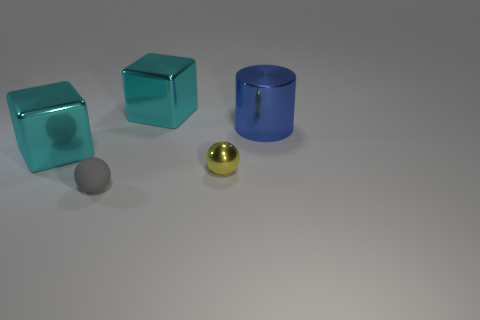What color is the big metal cylinder?
Keep it short and to the point. Blue. How many other objects are the same size as the yellow shiny thing?
Keep it short and to the point. 1. What is the material of the object that is right of the gray rubber sphere and in front of the blue shiny thing?
Provide a succinct answer. Metal. Does the metallic cube that is behind the metal cylinder have the same size as the blue cylinder?
Offer a very short reply. Yes. Is the color of the rubber object the same as the shiny cylinder?
Your response must be concise. No. What number of large things are both to the left of the gray ball and on the right side of the shiny sphere?
Provide a succinct answer. 0. There is a shiny cube that is left of the cube behind the cylinder; what number of yellow balls are in front of it?
Your answer should be very brief. 1. What is the shape of the tiny metal thing?
Give a very brief answer. Sphere. What number of things have the same material as the large cylinder?
Give a very brief answer. 3. There is a cylinder that is made of the same material as the tiny yellow object; what is its color?
Offer a terse response. Blue. 